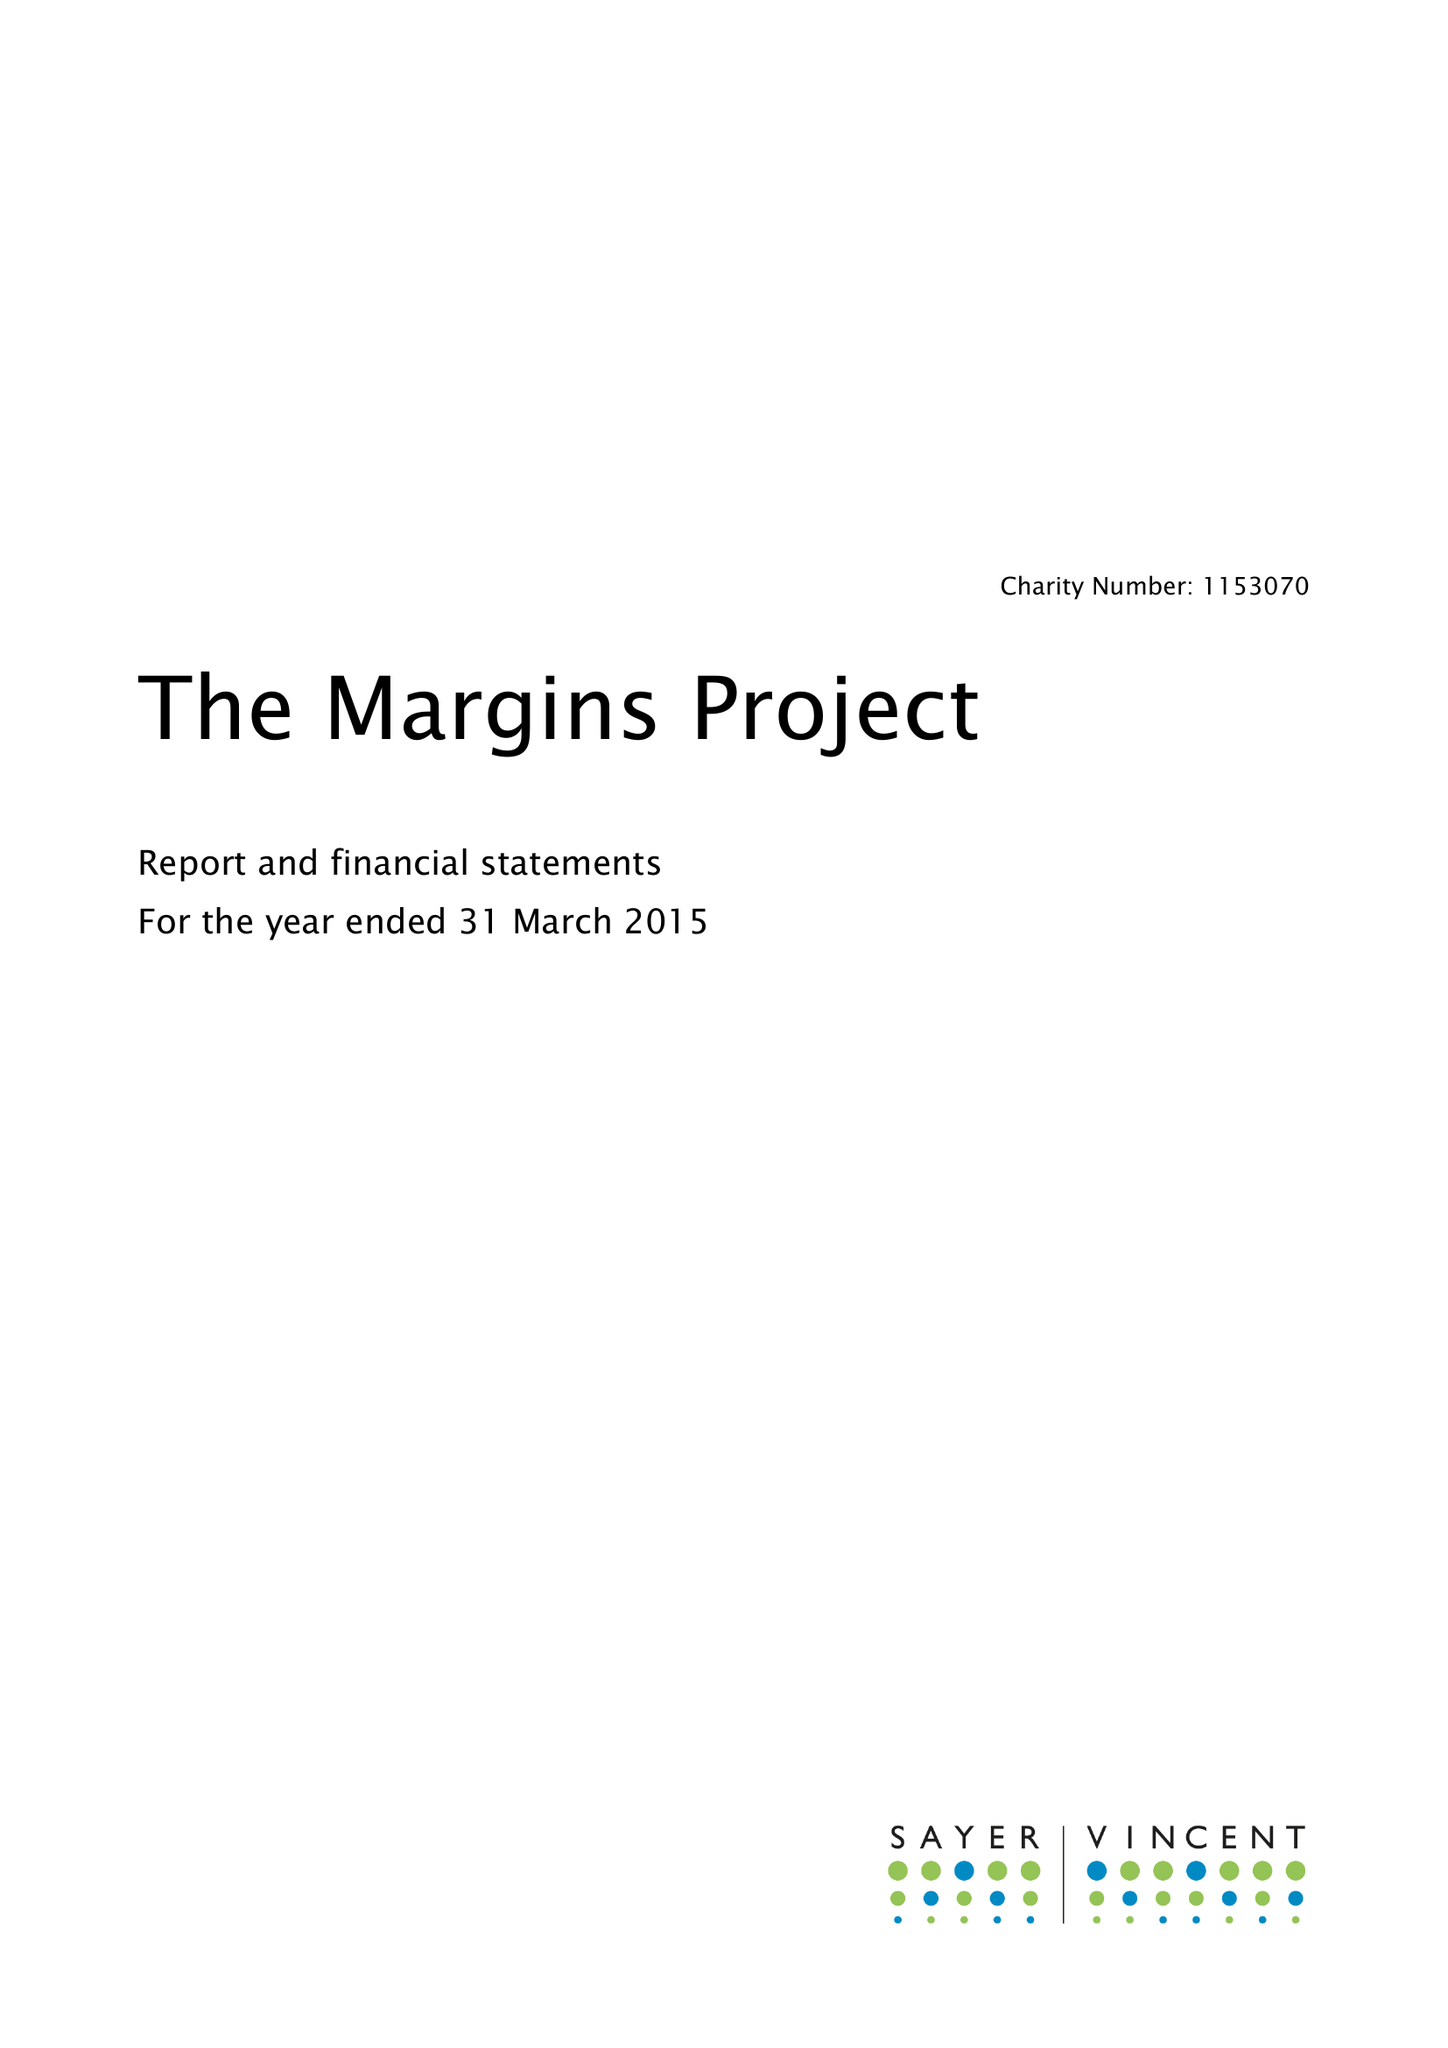What is the value for the address__post_town?
Answer the question using a single word or phrase. LONDON 